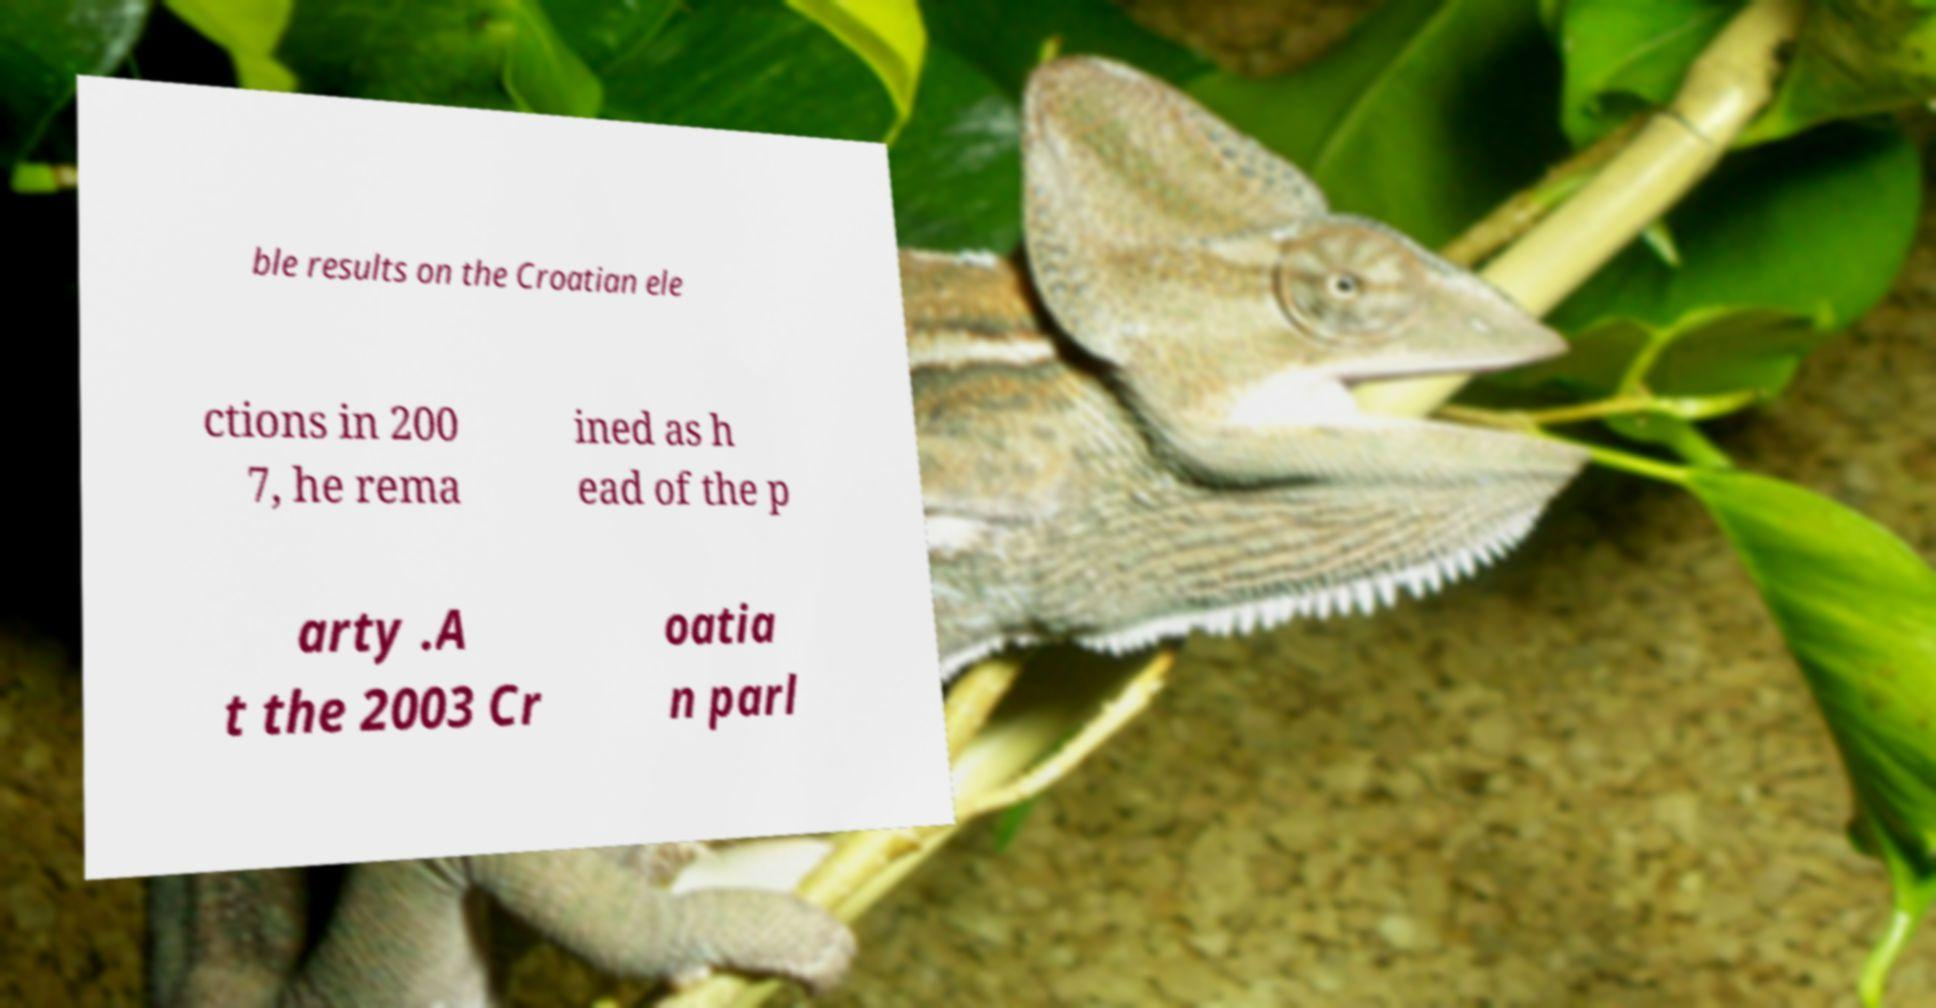There's text embedded in this image that I need extracted. Can you transcribe it verbatim? ble results on the Croatian ele ctions in 200 7, he rema ined as h ead of the p arty .A t the 2003 Cr oatia n parl 